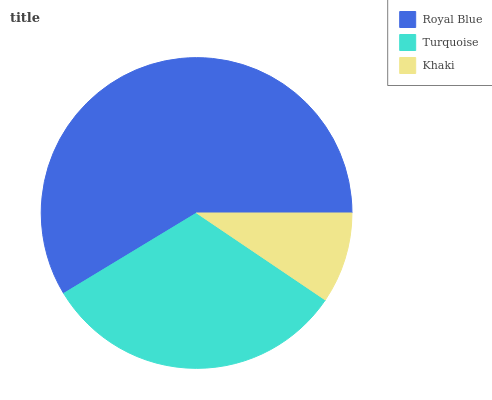Is Khaki the minimum?
Answer yes or no. Yes. Is Royal Blue the maximum?
Answer yes or no. Yes. Is Turquoise the minimum?
Answer yes or no. No. Is Turquoise the maximum?
Answer yes or no. No. Is Royal Blue greater than Turquoise?
Answer yes or no. Yes. Is Turquoise less than Royal Blue?
Answer yes or no. Yes. Is Turquoise greater than Royal Blue?
Answer yes or no. No. Is Royal Blue less than Turquoise?
Answer yes or no. No. Is Turquoise the high median?
Answer yes or no. Yes. Is Turquoise the low median?
Answer yes or no. Yes. Is Royal Blue the high median?
Answer yes or no. No. Is Royal Blue the low median?
Answer yes or no. No. 